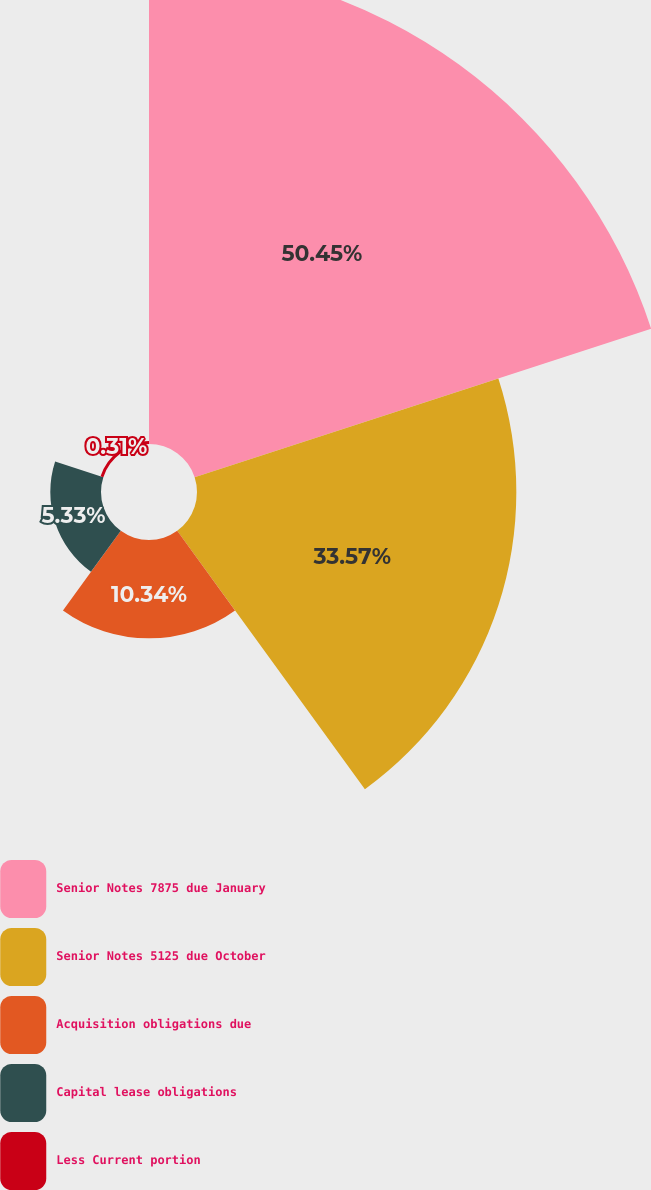Convert chart to OTSL. <chart><loc_0><loc_0><loc_500><loc_500><pie_chart><fcel>Senior Notes 7875 due January<fcel>Senior Notes 5125 due October<fcel>Acquisition obligations due<fcel>Capital lease obligations<fcel>Less Current portion<nl><fcel>50.46%<fcel>33.57%<fcel>10.34%<fcel>5.33%<fcel>0.31%<nl></chart> 